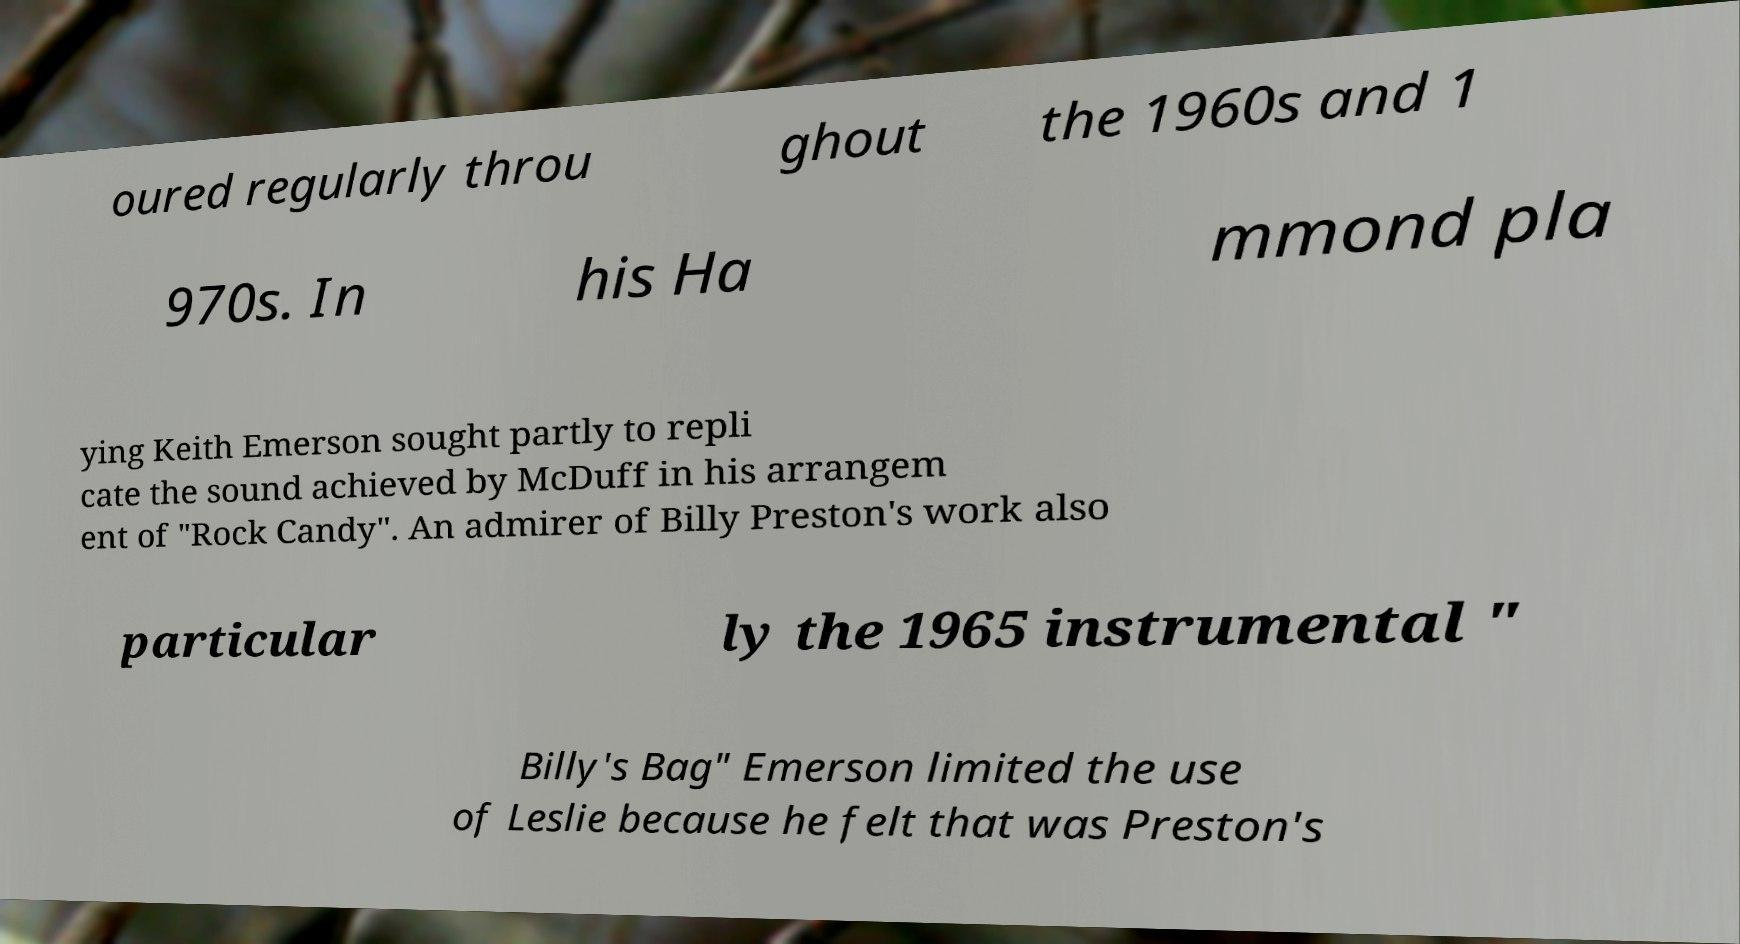Can you accurately transcribe the text from the provided image for me? oured regularly throu ghout the 1960s and 1 970s. In his Ha mmond pla ying Keith Emerson sought partly to repli cate the sound achieved by McDuff in his arrangem ent of "Rock Candy". An admirer of Billy Preston's work also particular ly the 1965 instrumental " Billy's Bag" Emerson limited the use of Leslie because he felt that was Preston's 